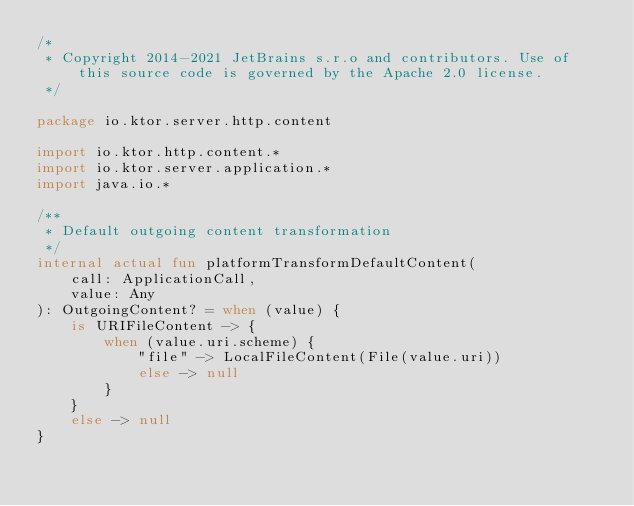Convert code to text. <code><loc_0><loc_0><loc_500><loc_500><_Kotlin_>/*
 * Copyright 2014-2021 JetBrains s.r.o and contributors. Use of this source code is governed by the Apache 2.0 license.
 */

package io.ktor.server.http.content

import io.ktor.http.content.*
import io.ktor.server.application.*
import java.io.*

/**
 * Default outgoing content transformation
 */
internal actual fun platformTransformDefaultContent(
    call: ApplicationCall,
    value: Any
): OutgoingContent? = when (value) {
    is URIFileContent -> {
        when (value.uri.scheme) {
            "file" -> LocalFileContent(File(value.uri))
            else -> null
        }
    }
    else -> null
}
</code> 